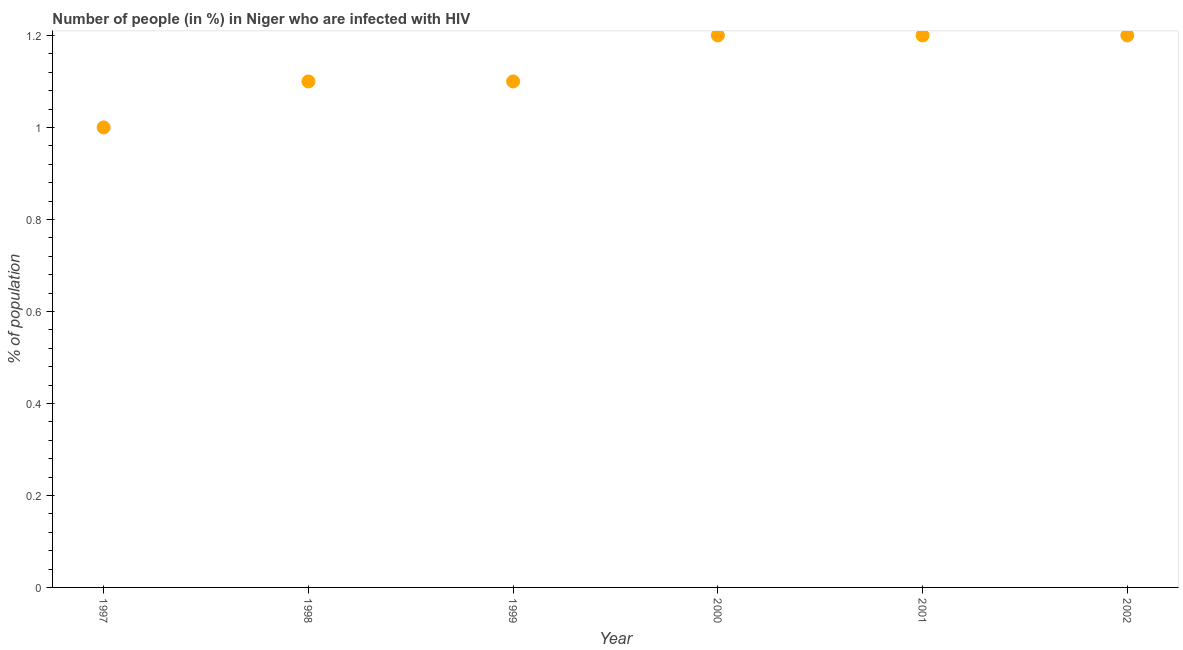Across all years, what is the maximum number of people infected with hiv?
Your response must be concise. 1.2. Across all years, what is the minimum number of people infected with hiv?
Make the answer very short. 1. In which year was the number of people infected with hiv maximum?
Provide a succinct answer. 2000. In which year was the number of people infected with hiv minimum?
Your answer should be compact. 1997. What is the sum of the number of people infected with hiv?
Keep it short and to the point. 6.8. What is the difference between the number of people infected with hiv in 1997 and 2002?
Your response must be concise. -0.2. What is the average number of people infected with hiv per year?
Your answer should be compact. 1.13. What is the median number of people infected with hiv?
Ensure brevity in your answer.  1.15. In how many years, is the number of people infected with hiv greater than 1.08 %?
Your response must be concise. 5. What is the ratio of the number of people infected with hiv in 1998 to that in 2002?
Your answer should be very brief. 0.92. What is the difference between the highest and the second highest number of people infected with hiv?
Provide a succinct answer. 0. What is the difference between the highest and the lowest number of people infected with hiv?
Keep it short and to the point. 0.2. In how many years, is the number of people infected with hiv greater than the average number of people infected with hiv taken over all years?
Your answer should be compact. 3. How many years are there in the graph?
Give a very brief answer. 6. Does the graph contain any zero values?
Provide a short and direct response. No. Does the graph contain grids?
Keep it short and to the point. No. What is the title of the graph?
Provide a short and direct response. Number of people (in %) in Niger who are infected with HIV. What is the label or title of the Y-axis?
Offer a very short reply. % of population. What is the % of population in 1997?
Provide a succinct answer. 1. What is the % of population in 2001?
Provide a succinct answer. 1.2. What is the % of population in 2002?
Your response must be concise. 1.2. What is the difference between the % of population in 1997 and 1999?
Your answer should be very brief. -0.1. What is the difference between the % of population in 1997 and 2000?
Keep it short and to the point. -0.2. What is the difference between the % of population in 1997 and 2001?
Your response must be concise. -0.2. What is the difference between the % of population in 1997 and 2002?
Make the answer very short. -0.2. What is the difference between the % of population in 1998 and 1999?
Keep it short and to the point. 0. What is the difference between the % of population in 2000 and 2001?
Your response must be concise. 0. What is the difference between the % of population in 2000 and 2002?
Provide a succinct answer. 0. What is the ratio of the % of population in 1997 to that in 1998?
Your answer should be compact. 0.91. What is the ratio of the % of population in 1997 to that in 1999?
Provide a short and direct response. 0.91. What is the ratio of the % of population in 1997 to that in 2000?
Provide a short and direct response. 0.83. What is the ratio of the % of population in 1997 to that in 2001?
Offer a very short reply. 0.83. What is the ratio of the % of population in 1997 to that in 2002?
Your answer should be very brief. 0.83. What is the ratio of the % of population in 1998 to that in 2000?
Your answer should be very brief. 0.92. What is the ratio of the % of population in 1998 to that in 2001?
Your answer should be very brief. 0.92. What is the ratio of the % of population in 1998 to that in 2002?
Provide a succinct answer. 0.92. What is the ratio of the % of population in 1999 to that in 2000?
Offer a terse response. 0.92. What is the ratio of the % of population in 1999 to that in 2001?
Keep it short and to the point. 0.92. What is the ratio of the % of population in 1999 to that in 2002?
Your answer should be compact. 0.92. 